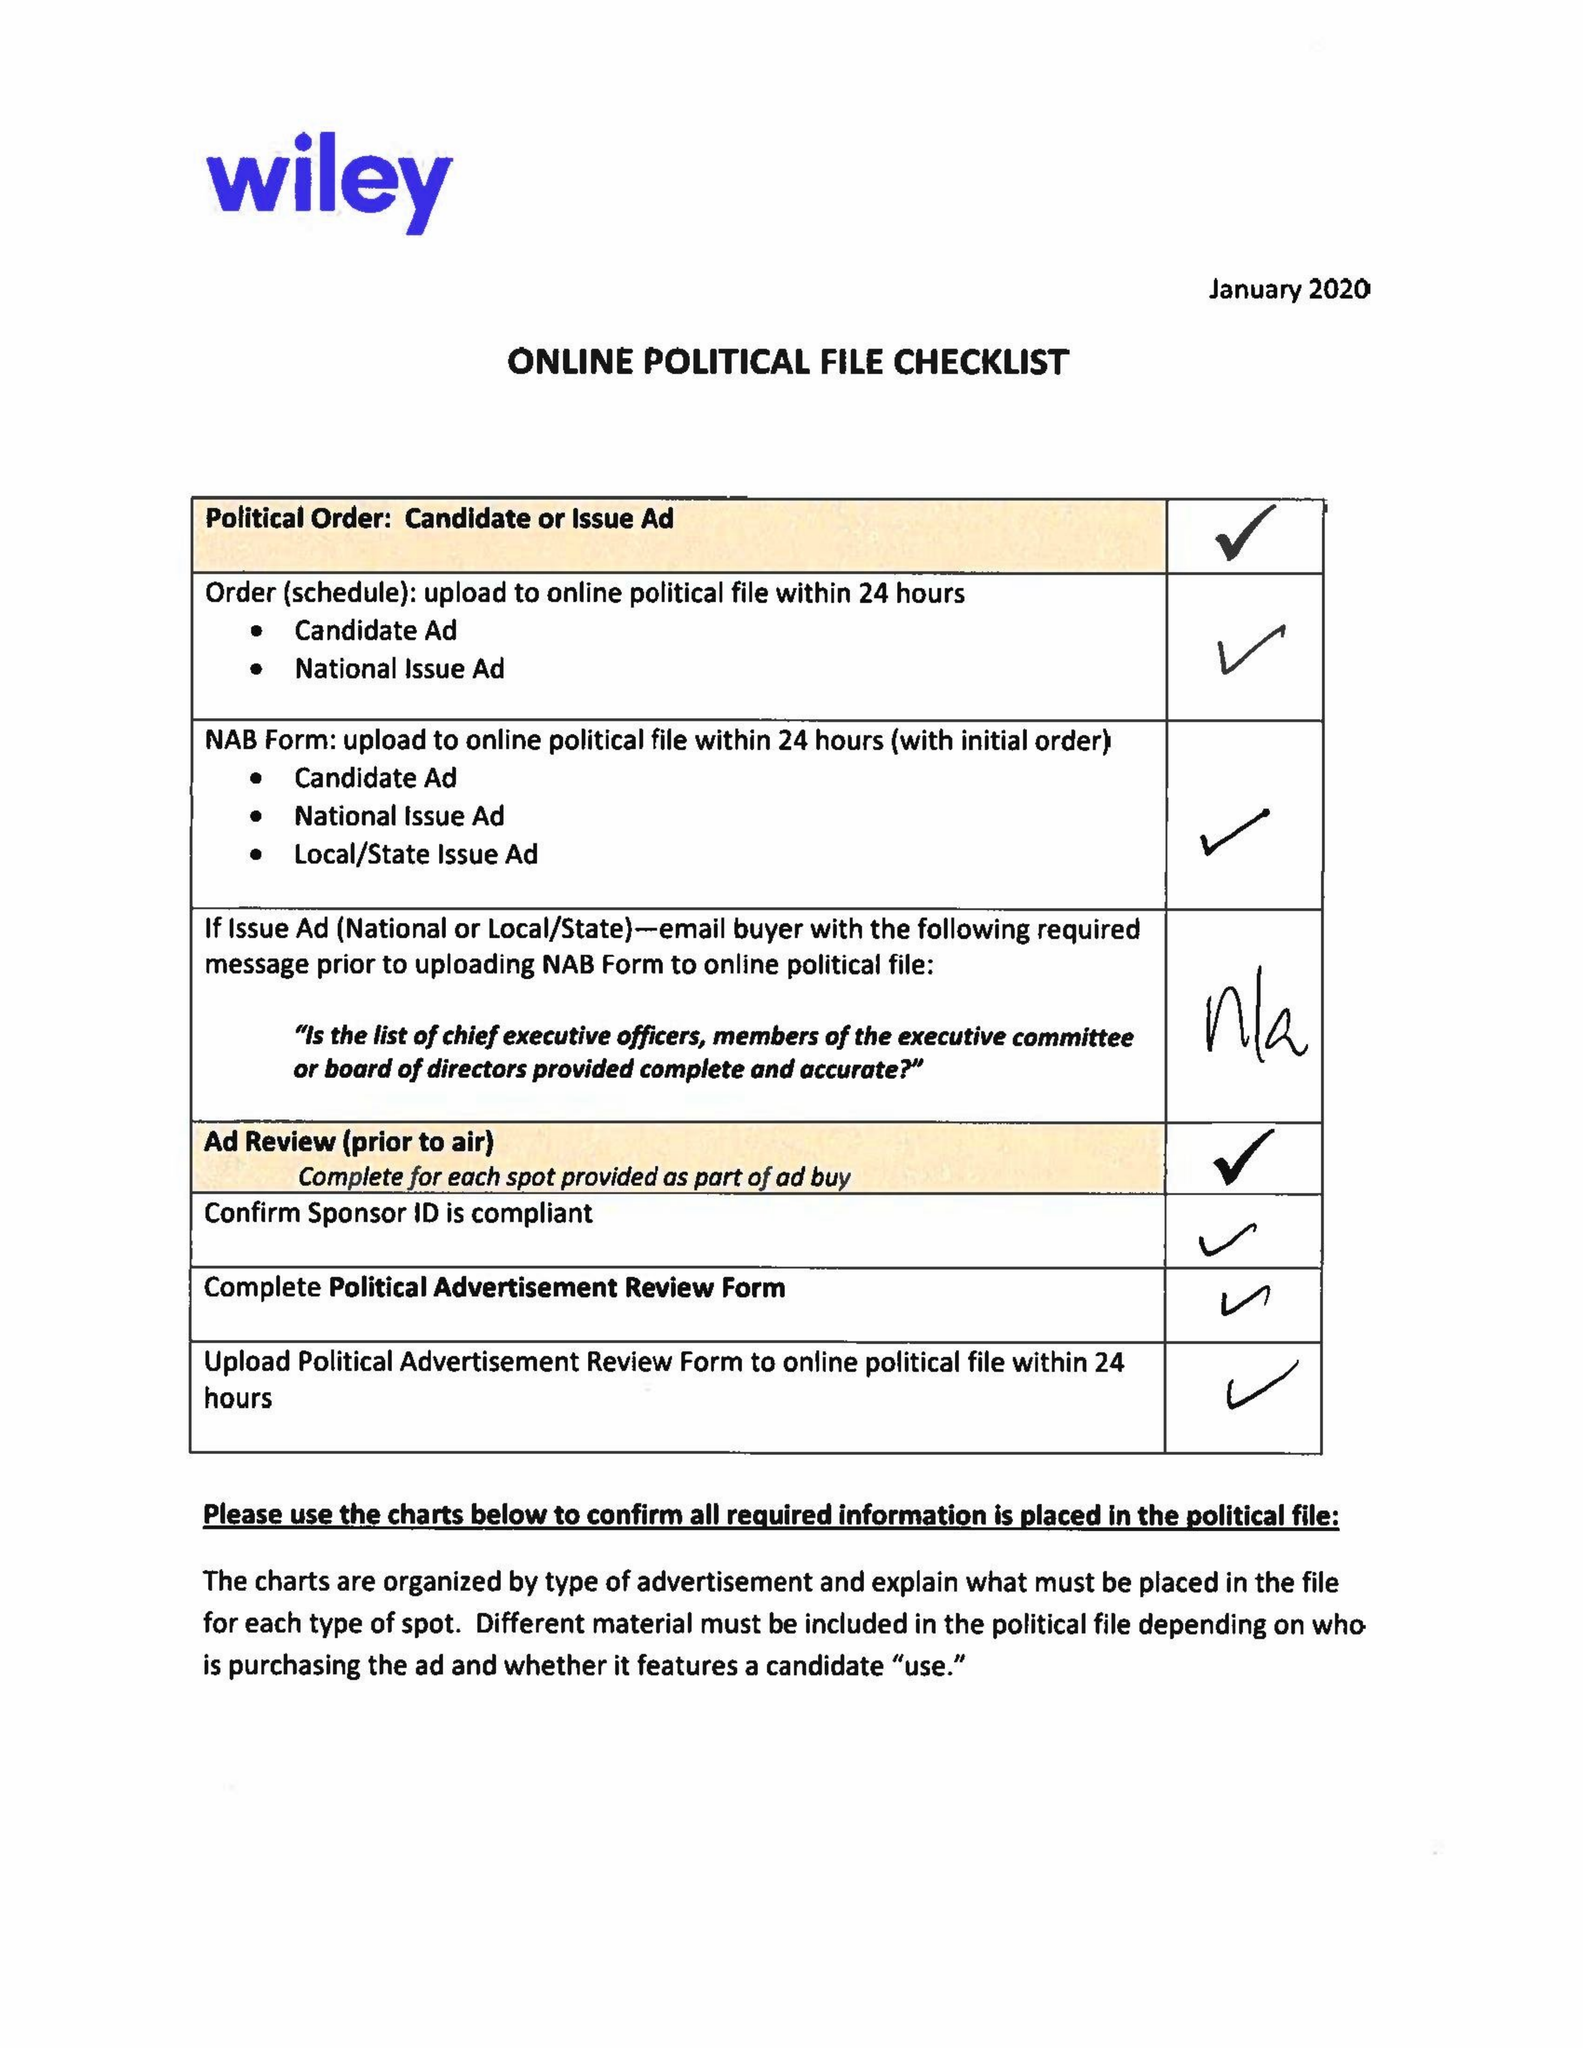What is the value for the flight_to?
Answer the question using a single word or phrase. 03/08/20 